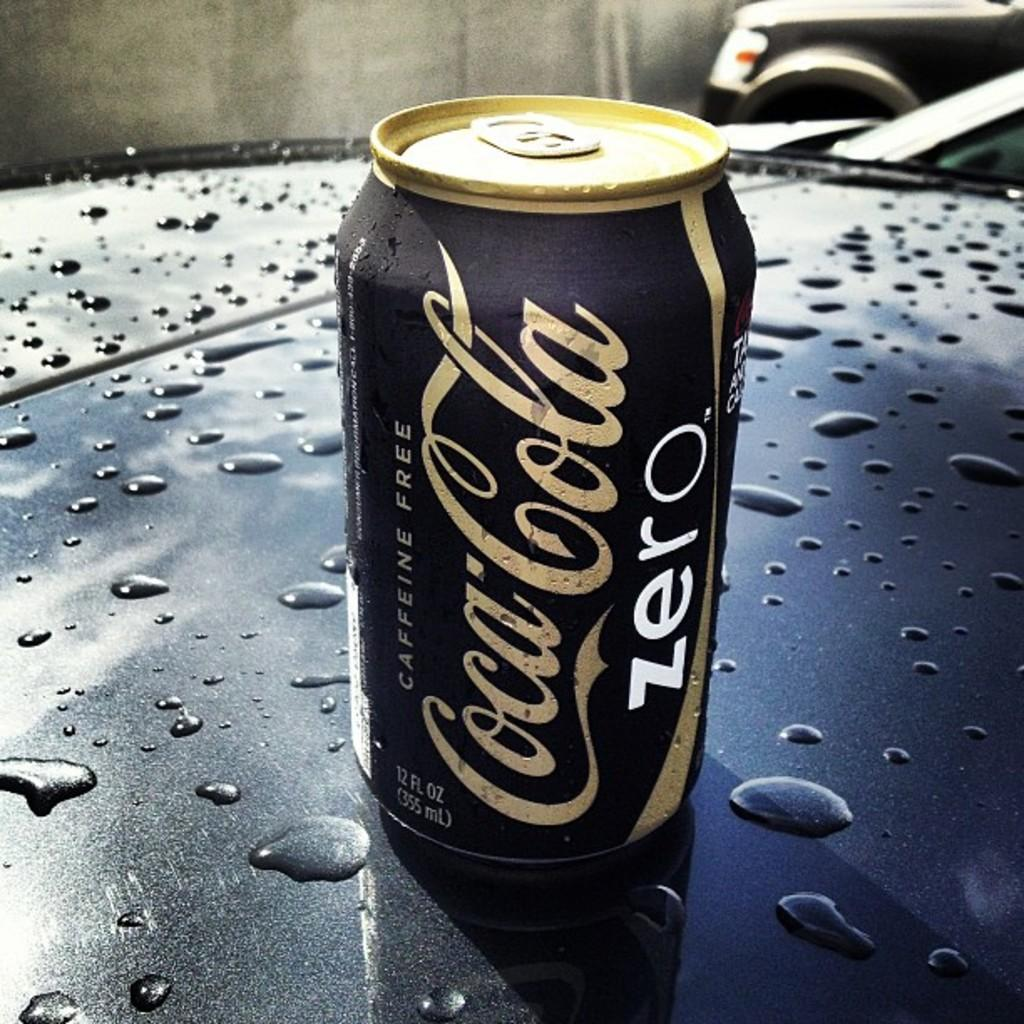What is the main object in the center of the image? There is a tin in the center of the image. Where is the tin located? The tin is placed on a table. What can be observed on the surface of the tin? There are water drops on the tin. What type of beam is holding up the garden in the image? There is no beam or garden present in the image; it only features a tin with water drops on a table. 